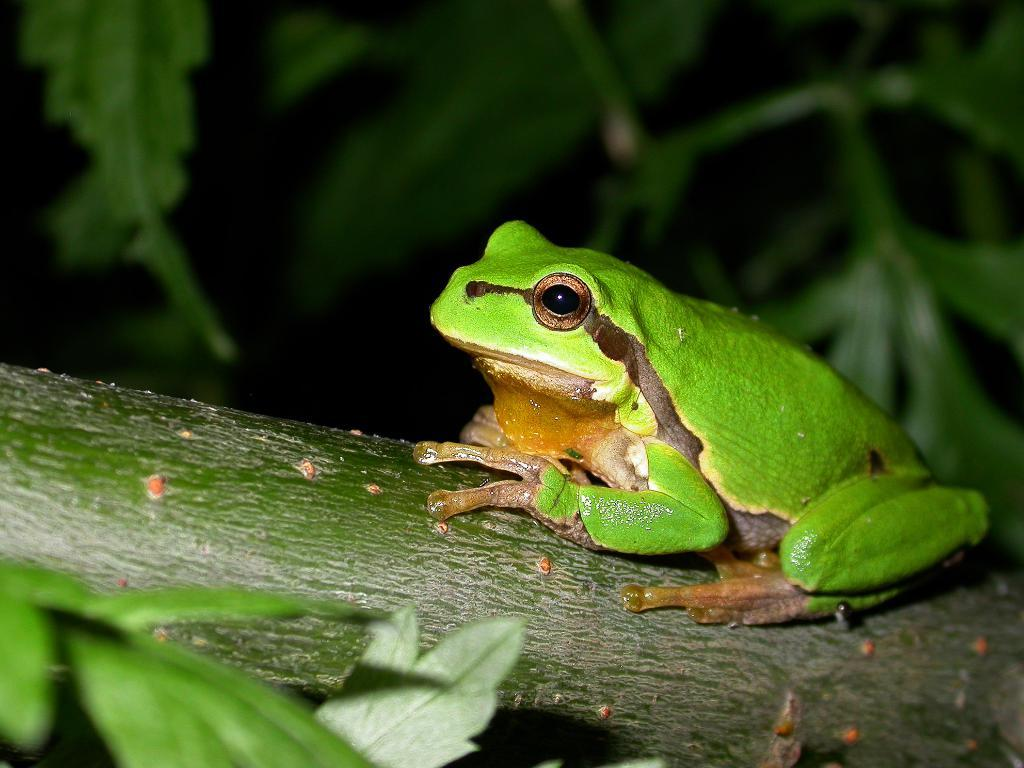What animal is present in the image? There is a frog in the image. What object is the frog sitting on? There is a branch in the image, and the frog is sitting on it. What type of vegetation can be seen on the left side of the image? There are leaves on the left side of the image. What can be seen in the background of the image? There are leaves in the background of the image. What type of ice can be seen melting on the branch in the image? There is no ice present in the image; it features a frog sitting on a branch with leaves in the background. 